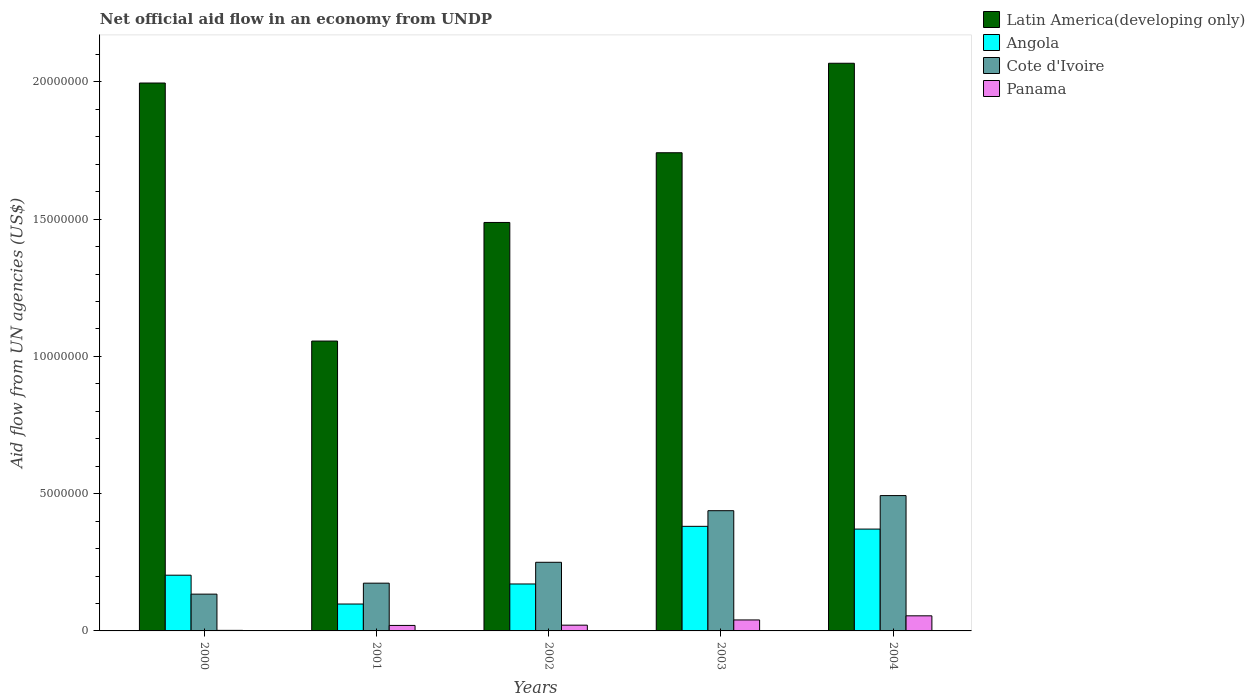How many groups of bars are there?
Provide a succinct answer. 5. Are the number of bars on each tick of the X-axis equal?
Your response must be concise. Yes. How many bars are there on the 5th tick from the left?
Your answer should be very brief. 4. How many bars are there on the 3rd tick from the right?
Provide a succinct answer. 4. What is the net official aid flow in Angola in 2002?
Your response must be concise. 1.71e+06. Across all years, what is the maximum net official aid flow in Cote d'Ivoire?
Provide a succinct answer. 4.93e+06. Across all years, what is the minimum net official aid flow in Panama?
Provide a short and direct response. 2.00e+04. In which year was the net official aid flow in Panama maximum?
Make the answer very short. 2004. In which year was the net official aid flow in Angola minimum?
Offer a very short reply. 2001. What is the total net official aid flow in Angola in the graph?
Your answer should be compact. 1.22e+07. What is the difference between the net official aid flow in Angola in 2001 and that in 2002?
Keep it short and to the point. -7.30e+05. What is the difference between the net official aid flow in Angola in 2000 and the net official aid flow in Latin America(developing only) in 2003?
Your answer should be compact. -1.54e+07. What is the average net official aid flow in Panama per year?
Offer a very short reply. 2.76e+05. In the year 2004, what is the difference between the net official aid flow in Angola and net official aid flow in Panama?
Your answer should be compact. 3.16e+06. What is the ratio of the net official aid flow in Latin America(developing only) in 2000 to that in 2002?
Your response must be concise. 1.34. Is the difference between the net official aid flow in Angola in 2002 and 2003 greater than the difference between the net official aid flow in Panama in 2002 and 2003?
Your answer should be compact. No. What is the difference between the highest and the second highest net official aid flow in Latin America(developing only)?
Your response must be concise. 7.20e+05. What is the difference between the highest and the lowest net official aid flow in Cote d'Ivoire?
Offer a terse response. 3.59e+06. In how many years, is the net official aid flow in Angola greater than the average net official aid flow in Angola taken over all years?
Provide a succinct answer. 2. Is it the case that in every year, the sum of the net official aid flow in Cote d'Ivoire and net official aid flow in Panama is greater than the sum of net official aid flow in Angola and net official aid flow in Latin America(developing only)?
Provide a short and direct response. Yes. What does the 3rd bar from the left in 2002 represents?
Give a very brief answer. Cote d'Ivoire. What does the 2nd bar from the right in 2000 represents?
Your answer should be very brief. Cote d'Ivoire. Is it the case that in every year, the sum of the net official aid flow in Angola and net official aid flow in Latin America(developing only) is greater than the net official aid flow in Cote d'Ivoire?
Provide a succinct answer. Yes. How many bars are there?
Give a very brief answer. 20. How many years are there in the graph?
Your answer should be very brief. 5. Does the graph contain grids?
Offer a very short reply. No. Where does the legend appear in the graph?
Give a very brief answer. Top right. How many legend labels are there?
Offer a terse response. 4. What is the title of the graph?
Your answer should be very brief. Net official aid flow in an economy from UNDP. What is the label or title of the X-axis?
Ensure brevity in your answer.  Years. What is the label or title of the Y-axis?
Your answer should be very brief. Aid flow from UN agencies (US$). What is the Aid flow from UN agencies (US$) of Latin America(developing only) in 2000?
Ensure brevity in your answer.  2.00e+07. What is the Aid flow from UN agencies (US$) of Angola in 2000?
Your answer should be compact. 2.03e+06. What is the Aid flow from UN agencies (US$) in Cote d'Ivoire in 2000?
Offer a terse response. 1.34e+06. What is the Aid flow from UN agencies (US$) of Panama in 2000?
Offer a terse response. 2.00e+04. What is the Aid flow from UN agencies (US$) of Latin America(developing only) in 2001?
Keep it short and to the point. 1.06e+07. What is the Aid flow from UN agencies (US$) of Angola in 2001?
Your answer should be very brief. 9.80e+05. What is the Aid flow from UN agencies (US$) in Cote d'Ivoire in 2001?
Your answer should be compact. 1.74e+06. What is the Aid flow from UN agencies (US$) of Panama in 2001?
Provide a short and direct response. 2.00e+05. What is the Aid flow from UN agencies (US$) in Latin America(developing only) in 2002?
Your answer should be very brief. 1.49e+07. What is the Aid flow from UN agencies (US$) in Angola in 2002?
Provide a short and direct response. 1.71e+06. What is the Aid flow from UN agencies (US$) in Cote d'Ivoire in 2002?
Offer a very short reply. 2.50e+06. What is the Aid flow from UN agencies (US$) of Latin America(developing only) in 2003?
Keep it short and to the point. 1.74e+07. What is the Aid flow from UN agencies (US$) of Angola in 2003?
Offer a terse response. 3.81e+06. What is the Aid flow from UN agencies (US$) of Cote d'Ivoire in 2003?
Ensure brevity in your answer.  4.38e+06. What is the Aid flow from UN agencies (US$) of Panama in 2003?
Offer a very short reply. 4.00e+05. What is the Aid flow from UN agencies (US$) of Latin America(developing only) in 2004?
Make the answer very short. 2.07e+07. What is the Aid flow from UN agencies (US$) in Angola in 2004?
Offer a terse response. 3.71e+06. What is the Aid flow from UN agencies (US$) of Cote d'Ivoire in 2004?
Ensure brevity in your answer.  4.93e+06. Across all years, what is the maximum Aid flow from UN agencies (US$) of Latin America(developing only)?
Offer a very short reply. 2.07e+07. Across all years, what is the maximum Aid flow from UN agencies (US$) in Angola?
Make the answer very short. 3.81e+06. Across all years, what is the maximum Aid flow from UN agencies (US$) in Cote d'Ivoire?
Provide a succinct answer. 4.93e+06. Across all years, what is the minimum Aid flow from UN agencies (US$) of Latin America(developing only)?
Keep it short and to the point. 1.06e+07. Across all years, what is the minimum Aid flow from UN agencies (US$) in Angola?
Make the answer very short. 9.80e+05. Across all years, what is the minimum Aid flow from UN agencies (US$) of Cote d'Ivoire?
Provide a short and direct response. 1.34e+06. Across all years, what is the minimum Aid flow from UN agencies (US$) in Panama?
Make the answer very short. 2.00e+04. What is the total Aid flow from UN agencies (US$) of Latin America(developing only) in the graph?
Your response must be concise. 8.35e+07. What is the total Aid flow from UN agencies (US$) in Angola in the graph?
Provide a short and direct response. 1.22e+07. What is the total Aid flow from UN agencies (US$) of Cote d'Ivoire in the graph?
Ensure brevity in your answer.  1.49e+07. What is the total Aid flow from UN agencies (US$) in Panama in the graph?
Provide a short and direct response. 1.38e+06. What is the difference between the Aid flow from UN agencies (US$) of Latin America(developing only) in 2000 and that in 2001?
Give a very brief answer. 9.40e+06. What is the difference between the Aid flow from UN agencies (US$) of Angola in 2000 and that in 2001?
Your answer should be very brief. 1.05e+06. What is the difference between the Aid flow from UN agencies (US$) in Cote d'Ivoire in 2000 and that in 2001?
Provide a short and direct response. -4.00e+05. What is the difference between the Aid flow from UN agencies (US$) in Latin America(developing only) in 2000 and that in 2002?
Give a very brief answer. 5.08e+06. What is the difference between the Aid flow from UN agencies (US$) in Angola in 2000 and that in 2002?
Your answer should be very brief. 3.20e+05. What is the difference between the Aid flow from UN agencies (US$) of Cote d'Ivoire in 2000 and that in 2002?
Make the answer very short. -1.16e+06. What is the difference between the Aid flow from UN agencies (US$) in Panama in 2000 and that in 2002?
Offer a very short reply. -1.90e+05. What is the difference between the Aid flow from UN agencies (US$) of Latin America(developing only) in 2000 and that in 2003?
Provide a short and direct response. 2.54e+06. What is the difference between the Aid flow from UN agencies (US$) in Angola in 2000 and that in 2003?
Keep it short and to the point. -1.78e+06. What is the difference between the Aid flow from UN agencies (US$) in Cote d'Ivoire in 2000 and that in 2003?
Keep it short and to the point. -3.04e+06. What is the difference between the Aid flow from UN agencies (US$) of Panama in 2000 and that in 2003?
Ensure brevity in your answer.  -3.80e+05. What is the difference between the Aid flow from UN agencies (US$) in Latin America(developing only) in 2000 and that in 2004?
Your answer should be very brief. -7.20e+05. What is the difference between the Aid flow from UN agencies (US$) in Angola in 2000 and that in 2004?
Provide a succinct answer. -1.68e+06. What is the difference between the Aid flow from UN agencies (US$) of Cote d'Ivoire in 2000 and that in 2004?
Offer a terse response. -3.59e+06. What is the difference between the Aid flow from UN agencies (US$) in Panama in 2000 and that in 2004?
Your response must be concise. -5.30e+05. What is the difference between the Aid flow from UN agencies (US$) in Latin America(developing only) in 2001 and that in 2002?
Give a very brief answer. -4.32e+06. What is the difference between the Aid flow from UN agencies (US$) of Angola in 2001 and that in 2002?
Your response must be concise. -7.30e+05. What is the difference between the Aid flow from UN agencies (US$) of Cote d'Ivoire in 2001 and that in 2002?
Offer a terse response. -7.60e+05. What is the difference between the Aid flow from UN agencies (US$) in Panama in 2001 and that in 2002?
Your answer should be very brief. -10000. What is the difference between the Aid flow from UN agencies (US$) of Latin America(developing only) in 2001 and that in 2003?
Offer a very short reply. -6.86e+06. What is the difference between the Aid flow from UN agencies (US$) of Angola in 2001 and that in 2003?
Ensure brevity in your answer.  -2.83e+06. What is the difference between the Aid flow from UN agencies (US$) of Cote d'Ivoire in 2001 and that in 2003?
Provide a succinct answer. -2.64e+06. What is the difference between the Aid flow from UN agencies (US$) in Panama in 2001 and that in 2003?
Keep it short and to the point. -2.00e+05. What is the difference between the Aid flow from UN agencies (US$) in Latin America(developing only) in 2001 and that in 2004?
Offer a terse response. -1.01e+07. What is the difference between the Aid flow from UN agencies (US$) in Angola in 2001 and that in 2004?
Provide a short and direct response. -2.73e+06. What is the difference between the Aid flow from UN agencies (US$) of Cote d'Ivoire in 2001 and that in 2004?
Provide a short and direct response. -3.19e+06. What is the difference between the Aid flow from UN agencies (US$) of Panama in 2001 and that in 2004?
Your response must be concise. -3.50e+05. What is the difference between the Aid flow from UN agencies (US$) in Latin America(developing only) in 2002 and that in 2003?
Offer a very short reply. -2.54e+06. What is the difference between the Aid flow from UN agencies (US$) of Angola in 2002 and that in 2003?
Your answer should be very brief. -2.10e+06. What is the difference between the Aid flow from UN agencies (US$) of Cote d'Ivoire in 2002 and that in 2003?
Give a very brief answer. -1.88e+06. What is the difference between the Aid flow from UN agencies (US$) of Latin America(developing only) in 2002 and that in 2004?
Keep it short and to the point. -5.80e+06. What is the difference between the Aid flow from UN agencies (US$) of Cote d'Ivoire in 2002 and that in 2004?
Your answer should be very brief. -2.43e+06. What is the difference between the Aid flow from UN agencies (US$) in Latin America(developing only) in 2003 and that in 2004?
Your response must be concise. -3.26e+06. What is the difference between the Aid flow from UN agencies (US$) in Cote d'Ivoire in 2003 and that in 2004?
Offer a terse response. -5.50e+05. What is the difference between the Aid flow from UN agencies (US$) of Latin America(developing only) in 2000 and the Aid flow from UN agencies (US$) of Angola in 2001?
Ensure brevity in your answer.  1.90e+07. What is the difference between the Aid flow from UN agencies (US$) of Latin America(developing only) in 2000 and the Aid flow from UN agencies (US$) of Cote d'Ivoire in 2001?
Your answer should be very brief. 1.82e+07. What is the difference between the Aid flow from UN agencies (US$) in Latin America(developing only) in 2000 and the Aid flow from UN agencies (US$) in Panama in 2001?
Offer a terse response. 1.98e+07. What is the difference between the Aid flow from UN agencies (US$) of Angola in 2000 and the Aid flow from UN agencies (US$) of Cote d'Ivoire in 2001?
Provide a short and direct response. 2.90e+05. What is the difference between the Aid flow from UN agencies (US$) in Angola in 2000 and the Aid flow from UN agencies (US$) in Panama in 2001?
Ensure brevity in your answer.  1.83e+06. What is the difference between the Aid flow from UN agencies (US$) in Cote d'Ivoire in 2000 and the Aid flow from UN agencies (US$) in Panama in 2001?
Make the answer very short. 1.14e+06. What is the difference between the Aid flow from UN agencies (US$) of Latin America(developing only) in 2000 and the Aid flow from UN agencies (US$) of Angola in 2002?
Your answer should be very brief. 1.82e+07. What is the difference between the Aid flow from UN agencies (US$) of Latin America(developing only) in 2000 and the Aid flow from UN agencies (US$) of Cote d'Ivoire in 2002?
Your answer should be compact. 1.75e+07. What is the difference between the Aid flow from UN agencies (US$) in Latin America(developing only) in 2000 and the Aid flow from UN agencies (US$) in Panama in 2002?
Make the answer very short. 1.98e+07. What is the difference between the Aid flow from UN agencies (US$) in Angola in 2000 and the Aid flow from UN agencies (US$) in Cote d'Ivoire in 2002?
Your response must be concise. -4.70e+05. What is the difference between the Aid flow from UN agencies (US$) in Angola in 2000 and the Aid flow from UN agencies (US$) in Panama in 2002?
Provide a short and direct response. 1.82e+06. What is the difference between the Aid flow from UN agencies (US$) of Cote d'Ivoire in 2000 and the Aid flow from UN agencies (US$) of Panama in 2002?
Your answer should be compact. 1.13e+06. What is the difference between the Aid flow from UN agencies (US$) of Latin America(developing only) in 2000 and the Aid flow from UN agencies (US$) of Angola in 2003?
Your answer should be very brief. 1.62e+07. What is the difference between the Aid flow from UN agencies (US$) in Latin America(developing only) in 2000 and the Aid flow from UN agencies (US$) in Cote d'Ivoire in 2003?
Offer a very short reply. 1.56e+07. What is the difference between the Aid flow from UN agencies (US$) in Latin America(developing only) in 2000 and the Aid flow from UN agencies (US$) in Panama in 2003?
Provide a short and direct response. 1.96e+07. What is the difference between the Aid flow from UN agencies (US$) in Angola in 2000 and the Aid flow from UN agencies (US$) in Cote d'Ivoire in 2003?
Offer a terse response. -2.35e+06. What is the difference between the Aid flow from UN agencies (US$) in Angola in 2000 and the Aid flow from UN agencies (US$) in Panama in 2003?
Your response must be concise. 1.63e+06. What is the difference between the Aid flow from UN agencies (US$) in Cote d'Ivoire in 2000 and the Aid flow from UN agencies (US$) in Panama in 2003?
Offer a very short reply. 9.40e+05. What is the difference between the Aid flow from UN agencies (US$) in Latin America(developing only) in 2000 and the Aid flow from UN agencies (US$) in Angola in 2004?
Provide a short and direct response. 1.62e+07. What is the difference between the Aid flow from UN agencies (US$) of Latin America(developing only) in 2000 and the Aid flow from UN agencies (US$) of Cote d'Ivoire in 2004?
Provide a short and direct response. 1.50e+07. What is the difference between the Aid flow from UN agencies (US$) in Latin America(developing only) in 2000 and the Aid flow from UN agencies (US$) in Panama in 2004?
Offer a very short reply. 1.94e+07. What is the difference between the Aid flow from UN agencies (US$) of Angola in 2000 and the Aid flow from UN agencies (US$) of Cote d'Ivoire in 2004?
Provide a short and direct response. -2.90e+06. What is the difference between the Aid flow from UN agencies (US$) in Angola in 2000 and the Aid flow from UN agencies (US$) in Panama in 2004?
Make the answer very short. 1.48e+06. What is the difference between the Aid flow from UN agencies (US$) in Cote d'Ivoire in 2000 and the Aid flow from UN agencies (US$) in Panama in 2004?
Offer a terse response. 7.90e+05. What is the difference between the Aid flow from UN agencies (US$) in Latin America(developing only) in 2001 and the Aid flow from UN agencies (US$) in Angola in 2002?
Offer a terse response. 8.85e+06. What is the difference between the Aid flow from UN agencies (US$) of Latin America(developing only) in 2001 and the Aid flow from UN agencies (US$) of Cote d'Ivoire in 2002?
Keep it short and to the point. 8.06e+06. What is the difference between the Aid flow from UN agencies (US$) in Latin America(developing only) in 2001 and the Aid flow from UN agencies (US$) in Panama in 2002?
Offer a very short reply. 1.04e+07. What is the difference between the Aid flow from UN agencies (US$) in Angola in 2001 and the Aid flow from UN agencies (US$) in Cote d'Ivoire in 2002?
Provide a short and direct response. -1.52e+06. What is the difference between the Aid flow from UN agencies (US$) of Angola in 2001 and the Aid flow from UN agencies (US$) of Panama in 2002?
Provide a succinct answer. 7.70e+05. What is the difference between the Aid flow from UN agencies (US$) in Cote d'Ivoire in 2001 and the Aid flow from UN agencies (US$) in Panama in 2002?
Your response must be concise. 1.53e+06. What is the difference between the Aid flow from UN agencies (US$) in Latin America(developing only) in 2001 and the Aid flow from UN agencies (US$) in Angola in 2003?
Ensure brevity in your answer.  6.75e+06. What is the difference between the Aid flow from UN agencies (US$) in Latin America(developing only) in 2001 and the Aid flow from UN agencies (US$) in Cote d'Ivoire in 2003?
Your response must be concise. 6.18e+06. What is the difference between the Aid flow from UN agencies (US$) in Latin America(developing only) in 2001 and the Aid flow from UN agencies (US$) in Panama in 2003?
Ensure brevity in your answer.  1.02e+07. What is the difference between the Aid flow from UN agencies (US$) in Angola in 2001 and the Aid flow from UN agencies (US$) in Cote d'Ivoire in 2003?
Offer a terse response. -3.40e+06. What is the difference between the Aid flow from UN agencies (US$) of Angola in 2001 and the Aid flow from UN agencies (US$) of Panama in 2003?
Provide a short and direct response. 5.80e+05. What is the difference between the Aid flow from UN agencies (US$) of Cote d'Ivoire in 2001 and the Aid flow from UN agencies (US$) of Panama in 2003?
Provide a succinct answer. 1.34e+06. What is the difference between the Aid flow from UN agencies (US$) in Latin America(developing only) in 2001 and the Aid flow from UN agencies (US$) in Angola in 2004?
Your response must be concise. 6.85e+06. What is the difference between the Aid flow from UN agencies (US$) of Latin America(developing only) in 2001 and the Aid flow from UN agencies (US$) of Cote d'Ivoire in 2004?
Your answer should be very brief. 5.63e+06. What is the difference between the Aid flow from UN agencies (US$) in Latin America(developing only) in 2001 and the Aid flow from UN agencies (US$) in Panama in 2004?
Your answer should be very brief. 1.00e+07. What is the difference between the Aid flow from UN agencies (US$) in Angola in 2001 and the Aid flow from UN agencies (US$) in Cote d'Ivoire in 2004?
Provide a short and direct response. -3.95e+06. What is the difference between the Aid flow from UN agencies (US$) of Angola in 2001 and the Aid flow from UN agencies (US$) of Panama in 2004?
Offer a very short reply. 4.30e+05. What is the difference between the Aid flow from UN agencies (US$) of Cote d'Ivoire in 2001 and the Aid flow from UN agencies (US$) of Panama in 2004?
Provide a short and direct response. 1.19e+06. What is the difference between the Aid flow from UN agencies (US$) in Latin America(developing only) in 2002 and the Aid flow from UN agencies (US$) in Angola in 2003?
Ensure brevity in your answer.  1.11e+07. What is the difference between the Aid flow from UN agencies (US$) of Latin America(developing only) in 2002 and the Aid flow from UN agencies (US$) of Cote d'Ivoire in 2003?
Provide a succinct answer. 1.05e+07. What is the difference between the Aid flow from UN agencies (US$) of Latin America(developing only) in 2002 and the Aid flow from UN agencies (US$) of Panama in 2003?
Offer a terse response. 1.45e+07. What is the difference between the Aid flow from UN agencies (US$) of Angola in 2002 and the Aid flow from UN agencies (US$) of Cote d'Ivoire in 2003?
Ensure brevity in your answer.  -2.67e+06. What is the difference between the Aid flow from UN agencies (US$) of Angola in 2002 and the Aid flow from UN agencies (US$) of Panama in 2003?
Provide a succinct answer. 1.31e+06. What is the difference between the Aid flow from UN agencies (US$) in Cote d'Ivoire in 2002 and the Aid flow from UN agencies (US$) in Panama in 2003?
Keep it short and to the point. 2.10e+06. What is the difference between the Aid flow from UN agencies (US$) in Latin America(developing only) in 2002 and the Aid flow from UN agencies (US$) in Angola in 2004?
Provide a succinct answer. 1.12e+07. What is the difference between the Aid flow from UN agencies (US$) in Latin America(developing only) in 2002 and the Aid flow from UN agencies (US$) in Cote d'Ivoire in 2004?
Offer a very short reply. 9.95e+06. What is the difference between the Aid flow from UN agencies (US$) in Latin America(developing only) in 2002 and the Aid flow from UN agencies (US$) in Panama in 2004?
Your answer should be compact. 1.43e+07. What is the difference between the Aid flow from UN agencies (US$) of Angola in 2002 and the Aid flow from UN agencies (US$) of Cote d'Ivoire in 2004?
Your answer should be compact. -3.22e+06. What is the difference between the Aid flow from UN agencies (US$) of Angola in 2002 and the Aid flow from UN agencies (US$) of Panama in 2004?
Offer a terse response. 1.16e+06. What is the difference between the Aid flow from UN agencies (US$) in Cote d'Ivoire in 2002 and the Aid flow from UN agencies (US$) in Panama in 2004?
Offer a very short reply. 1.95e+06. What is the difference between the Aid flow from UN agencies (US$) of Latin America(developing only) in 2003 and the Aid flow from UN agencies (US$) of Angola in 2004?
Ensure brevity in your answer.  1.37e+07. What is the difference between the Aid flow from UN agencies (US$) of Latin America(developing only) in 2003 and the Aid flow from UN agencies (US$) of Cote d'Ivoire in 2004?
Your response must be concise. 1.25e+07. What is the difference between the Aid flow from UN agencies (US$) in Latin America(developing only) in 2003 and the Aid flow from UN agencies (US$) in Panama in 2004?
Your response must be concise. 1.69e+07. What is the difference between the Aid flow from UN agencies (US$) of Angola in 2003 and the Aid flow from UN agencies (US$) of Cote d'Ivoire in 2004?
Offer a terse response. -1.12e+06. What is the difference between the Aid flow from UN agencies (US$) in Angola in 2003 and the Aid flow from UN agencies (US$) in Panama in 2004?
Offer a terse response. 3.26e+06. What is the difference between the Aid flow from UN agencies (US$) of Cote d'Ivoire in 2003 and the Aid flow from UN agencies (US$) of Panama in 2004?
Your response must be concise. 3.83e+06. What is the average Aid flow from UN agencies (US$) of Latin America(developing only) per year?
Make the answer very short. 1.67e+07. What is the average Aid flow from UN agencies (US$) in Angola per year?
Give a very brief answer. 2.45e+06. What is the average Aid flow from UN agencies (US$) in Cote d'Ivoire per year?
Provide a succinct answer. 2.98e+06. What is the average Aid flow from UN agencies (US$) in Panama per year?
Keep it short and to the point. 2.76e+05. In the year 2000, what is the difference between the Aid flow from UN agencies (US$) in Latin America(developing only) and Aid flow from UN agencies (US$) in Angola?
Make the answer very short. 1.79e+07. In the year 2000, what is the difference between the Aid flow from UN agencies (US$) in Latin America(developing only) and Aid flow from UN agencies (US$) in Cote d'Ivoire?
Offer a terse response. 1.86e+07. In the year 2000, what is the difference between the Aid flow from UN agencies (US$) of Latin America(developing only) and Aid flow from UN agencies (US$) of Panama?
Offer a very short reply. 1.99e+07. In the year 2000, what is the difference between the Aid flow from UN agencies (US$) of Angola and Aid flow from UN agencies (US$) of Cote d'Ivoire?
Give a very brief answer. 6.90e+05. In the year 2000, what is the difference between the Aid flow from UN agencies (US$) in Angola and Aid flow from UN agencies (US$) in Panama?
Your answer should be compact. 2.01e+06. In the year 2000, what is the difference between the Aid flow from UN agencies (US$) in Cote d'Ivoire and Aid flow from UN agencies (US$) in Panama?
Provide a succinct answer. 1.32e+06. In the year 2001, what is the difference between the Aid flow from UN agencies (US$) in Latin America(developing only) and Aid flow from UN agencies (US$) in Angola?
Keep it short and to the point. 9.58e+06. In the year 2001, what is the difference between the Aid flow from UN agencies (US$) of Latin America(developing only) and Aid flow from UN agencies (US$) of Cote d'Ivoire?
Provide a short and direct response. 8.82e+06. In the year 2001, what is the difference between the Aid flow from UN agencies (US$) of Latin America(developing only) and Aid flow from UN agencies (US$) of Panama?
Keep it short and to the point. 1.04e+07. In the year 2001, what is the difference between the Aid flow from UN agencies (US$) of Angola and Aid flow from UN agencies (US$) of Cote d'Ivoire?
Your answer should be compact. -7.60e+05. In the year 2001, what is the difference between the Aid flow from UN agencies (US$) of Angola and Aid flow from UN agencies (US$) of Panama?
Your answer should be compact. 7.80e+05. In the year 2001, what is the difference between the Aid flow from UN agencies (US$) in Cote d'Ivoire and Aid flow from UN agencies (US$) in Panama?
Ensure brevity in your answer.  1.54e+06. In the year 2002, what is the difference between the Aid flow from UN agencies (US$) in Latin America(developing only) and Aid flow from UN agencies (US$) in Angola?
Provide a short and direct response. 1.32e+07. In the year 2002, what is the difference between the Aid flow from UN agencies (US$) in Latin America(developing only) and Aid flow from UN agencies (US$) in Cote d'Ivoire?
Your response must be concise. 1.24e+07. In the year 2002, what is the difference between the Aid flow from UN agencies (US$) in Latin America(developing only) and Aid flow from UN agencies (US$) in Panama?
Give a very brief answer. 1.47e+07. In the year 2002, what is the difference between the Aid flow from UN agencies (US$) of Angola and Aid flow from UN agencies (US$) of Cote d'Ivoire?
Offer a very short reply. -7.90e+05. In the year 2002, what is the difference between the Aid flow from UN agencies (US$) in Angola and Aid flow from UN agencies (US$) in Panama?
Your answer should be compact. 1.50e+06. In the year 2002, what is the difference between the Aid flow from UN agencies (US$) in Cote d'Ivoire and Aid flow from UN agencies (US$) in Panama?
Give a very brief answer. 2.29e+06. In the year 2003, what is the difference between the Aid flow from UN agencies (US$) of Latin America(developing only) and Aid flow from UN agencies (US$) of Angola?
Your answer should be very brief. 1.36e+07. In the year 2003, what is the difference between the Aid flow from UN agencies (US$) in Latin America(developing only) and Aid flow from UN agencies (US$) in Cote d'Ivoire?
Keep it short and to the point. 1.30e+07. In the year 2003, what is the difference between the Aid flow from UN agencies (US$) of Latin America(developing only) and Aid flow from UN agencies (US$) of Panama?
Your answer should be compact. 1.70e+07. In the year 2003, what is the difference between the Aid flow from UN agencies (US$) in Angola and Aid flow from UN agencies (US$) in Cote d'Ivoire?
Provide a short and direct response. -5.70e+05. In the year 2003, what is the difference between the Aid flow from UN agencies (US$) in Angola and Aid flow from UN agencies (US$) in Panama?
Give a very brief answer. 3.41e+06. In the year 2003, what is the difference between the Aid flow from UN agencies (US$) in Cote d'Ivoire and Aid flow from UN agencies (US$) in Panama?
Make the answer very short. 3.98e+06. In the year 2004, what is the difference between the Aid flow from UN agencies (US$) of Latin America(developing only) and Aid flow from UN agencies (US$) of Angola?
Your response must be concise. 1.70e+07. In the year 2004, what is the difference between the Aid flow from UN agencies (US$) in Latin America(developing only) and Aid flow from UN agencies (US$) in Cote d'Ivoire?
Offer a very short reply. 1.58e+07. In the year 2004, what is the difference between the Aid flow from UN agencies (US$) in Latin America(developing only) and Aid flow from UN agencies (US$) in Panama?
Your response must be concise. 2.01e+07. In the year 2004, what is the difference between the Aid flow from UN agencies (US$) in Angola and Aid flow from UN agencies (US$) in Cote d'Ivoire?
Make the answer very short. -1.22e+06. In the year 2004, what is the difference between the Aid flow from UN agencies (US$) in Angola and Aid flow from UN agencies (US$) in Panama?
Your answer should be compact. 3.16e+06. In the year 2004, what is the difference between the Aid flow from UN agencies (US$) in Cote d'Ivoire and Aid flow from UN agencies (US$) in Panama?
Your response must be concise. 4.38e+06. What is the ratio of the Aid flow from UN agencies (US$) in Latin America(developing only) in 2000 to that in 2001?
Give a very brief answer. 1.89. What is the ratio of the Aid flow from UN agencies (US$) of Angola in 2000 to that in 2001?
Provide a succinct answer. 2.07. What is the ratio of the Aid flow from UN agencies (US$) in Cote d'Ivoire in 2000 to that in 2001?
Provide a short and direct response. 0.77. What is the ratio of the Aid flow from UN agencies (US$) of Panama in 2000 to that in 2001?
Keep it short and to the point. 0.1. What is the ratio of the Aid flow from UN agencies (US$) of Latin America(developing only) in 2000 to that in 2002?
Offer a very short reply. 1.34. What is the ratio of the Aid flow from UN agencies (US$) of Angola in 2000 to that in 2002?
Make the answer very short. 1.19. What is the ratio of the Aid flow from UN agencies (US$) of Cote d'Ivoire in 2000 to that in 2002?
Your answer should be very brief. 0.54. What is the ratio of the Aid flow from UN agencies (US$) of Panama in 2000 to that in 2002?
Provide a succinct answer. 0.1. What is the ratio of the Aid flow from UN agencies (US$) of Latin America(developing only) in 2000 to that in 2003?
Keep it short and to the point. 1.15. What is the ratio of the Aid flow from UN agencies (US$) of Angola in 2000 to that in 2003?
Provide a short and direct response. 0.53. What is the ratio of the Aid flow from UN agencies (US$) in Cote d'Ivoire in 2000 to that in 2003?
Ensure brevity in your answer.  0.31. What is the ratio of the Aid flow from UN agencies (US$) in Latin America(developing only) in 2000 to that in 2004?
Ensure brevity in your answer.  0.97. What is the ratio of the Aid flow from UN agencies (US$) of Angola in 2000 to that in 2004?
Give a very brief answer. 0.55. What is the ratio of the Aid flow from UN agencies (US$) in Cote d'Ivoire in 2000 to that in 2004?
Your response must be concise. 0.27. What is the ratio of the Aid flow from UN agencies (US$) in Panama in 2000 to that in 2004?
Keep it short and to the point. 0.04. What is the ratio of the Aid flow from UN agencies (US$) in Latin America(developing only) in 2001 to that in 2002?
Provide a succinct answer. 0.71. What is the ratio of the Aid flow from UN agencies (US$) of Angola in 2001 to that in 2002?
Your answer should be very brief. 0.57. What is the ratio of the Aid flow from UN agencies (US$) in Cote d'Ivoire in 2001 to that in 2002?
Provide a short and direct response. 0.7. What is the ratio of the Aid flow from UN agencies (US$) in Latin America(developing only) in 2001 to that in 2003?
Offer a terse response. 0.61. What is the ratio of the Aid flow from UN agencies (US$) of Angola in 2001 to that in 2003?
Provide a succinct answer. 0.26. What is the ratio of the Aid flow from UN agencies (US$) in Cote d'Ivoire in 2001 to that in 2003?
Your response must be concise. 0.4. What is the ratio of the Aid flow from UN agencies (US$) of Latin America(developing only) in 2001 to that in 2004?
Give a very brief answer. 0.51. What is the ratio of the Aid flow from UN agencies (US$) of Angola in 2001 to that in 2004?
Provide a succinct answer. 0.26. What is the ratio of the Aid flow from UN agencies (US$) in Cote d'Ivoire in 2001 to that in 2004?
Your response must be concise. 0.35. What is the ratio of the Aid flow from UN agencies (US$) of Panama in 2001 to that in 2004?
Keep it short and to the point. 0.36. What is the ratio of the Aid flow from UN agencies (US$) in Latin America(developing only) in 2002 to that in 2003?
Provide a short and direct response. 0.85. What is the ratio of the Aid flow from UN agencies (US$) in Angola in 2002 to that in 2003?
Your response must be concise. 0.45. What is the ratio of the Aid flow from UN agencies (US$) of Cote d'Ivoire in 2002 to that in 2003?
Your response must be concise. 0.57. What is the ratio of the Aid flow from UN agencies (US$) of Panama in 2002 to that in 2003?
Provide a short and direct response. 0.53. What is the ratio of the Aid flow from UN agencies (US$) in Latin America(developing only) in 2002 to that in 2004?
Give a very brief answer. 0.72. What is the ratio of the Aid flow from UN agencies (US$) of Angola in 2002 to that in 2004?
Give a very brief answer. 0.46. What is the ratio of the Aid flow from UN agencies (US$) of Cote d'Ivoire in 2002 to that in 2004?
Provide a succinct answer. 0.51. What is the ratio of the Aid flow from UN agencies (US$) in Panama in 2002 to that in 2004?
Offer a terse response. 0.38. What is the ratio of the Aid flow from UN agencies (US$) of Latin America(developing only) in 2003 to that in 2004?
Your response must be concise. 0.84. What is the ratio of the Aid flow from UN agencies (US$) in Angola in 2003 to that in 2004?
Keep it short and to the point. 1.03. What is the ratio of the Aid flow from UN agencies (US$) of Cote d'Ivoire in 2003 to that in 2004?
Provide a short and direct response. 0.89. What is the ratio of the Aid flow from UN agencies (US$) in Panama in 2003 to that in 2004?
Make the answer very short. 0.73. What is the difference between the highest and the second highest Aid flow from UN agencies (US$) in Latin America(developing only)?
Ensure brevity in your answer.  7.20e+05. What is the difference between the highest and the second highest Aid flow from UN agencies (US$) in Angola?
Keep it short and to the point. 1.00e+05. What is the difference between the highest and the lowest Aid flow from UN agencies (US$) of Latin America(developing only)?
Make the answer very short. 1.01e+07. What is the difference between the highest and the lowest Aid flow from UN agencies (US$) in Angola?
Provide a succinct answer. 2.83e+06. What is the difference between the highest and the lowest Aid flow from UN agencies (US$) of Cote d'Ivoire?
Your answer should be very brief. 3.59e+06. What is the difference between the highest and the lowest Aid flow from UN agencies (US$) of Panama?
Make the answer very short. 5.30e+05. 